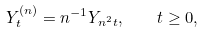Convert formula to latex. <formula><loc_0><loc_0><loc_500><loc_500>Y ^ { ( n ) } _ { t } = n ^ { - 1 } Y _ { n ^ { 2 } t } , \quad t \geq 0 ,</formula> 